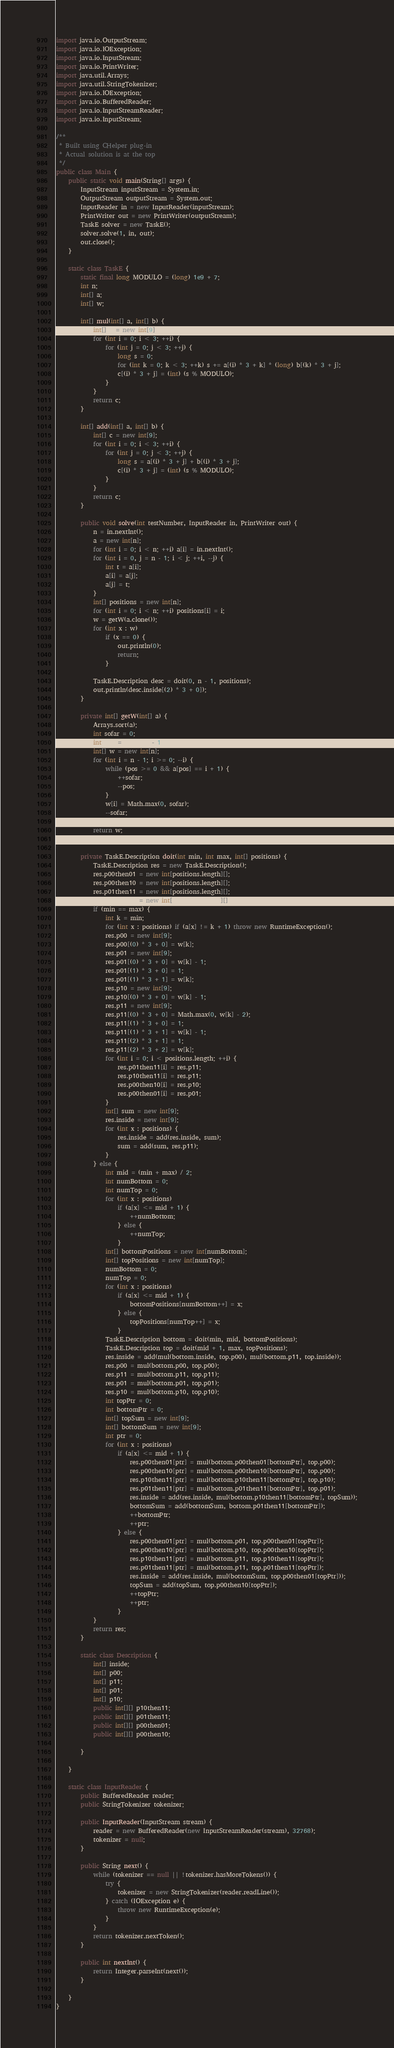<code> <loc_0><loc_0><loc_500><loc_500><_Java_>import java.io.OutputStream;
import java.io.IOException;
import java.io.InputStream;
import java.io.PrintWriter;
import java.util.Arrays;
import java.util.StringTokenizer;
import java.io.IOException;
import java.io.BufferedReader;
import java.io.InputStreamReader;
import java.io.InputStream;

/**
 * Built using CHelper plug-in
 * Actual solution is at the top
 */
public class Main {
    public static void main(String[] args) {
        InputStream inputStream = System.in;
        OutputStream outputStream = System.out;
        InputReader in = new InputReader(inputStream);
        PrintWriter out = new PrintWriter(outputStream);
        TaskE solver = new TaskE();
        solver.solve(1, in, out);
        out.close();
    }

    static class TaskE {
        static final long MODULO = (long) 1e9 + 7;
        int n;
        int[] a;
        int[] w;

        int[] mul(int[] a, int[] b) {
            int[] c = new int[9];
            for (int i = 0; i < 3; ++i) {
                for (int j = 0; j < 3; ++j) {
                    long s = 0;
                    for (int k = 0; k < 3; ++k) s += a[(i) * 3 + k] * (long) b[(k) * 3 + j];
                    c[(i) * 3 + j] = (int) (s % MODULO);
                }
            }
            return c;
        }

        int[] add(int[] a, int[] b) {
            int[] c = new int[9];
            for (int i = 0; i < 3; ++i) {
                for (int j = 0; j < 3; ++j) {
                    long s = a[(i) * 3 + j] + b[(i) * 3 + j];
                    c[(i) * 3 + j] = (int) (s % MODULO);
                }
            }
            return c;
        }

        public void solve(int testNumber, InputReader in, PrintWriter out) {
            n = in.nextInt();
            a = new int[n];
            for (int i = 0; i < n; ++i) a[i] = in.nextInt();
            for (int i = 0, j = n - 1; i < j; ++i, --j) {
                int t = a[i];
                a[i] = a[j];
                a[j] = t;
            }
            int[] positions = new int[n];
            for (int i = 0; i < n; ++i) positions[i] = i;
            w = getW(a.clone());
            for (int x : w)
                if (x == 0) {
                    out.println(0);
                    return;
                }

            TaskE.Description desc = doit(0, n - 1, positions);
            out.println(desc.inside[(2) * 3 + 0]);
        }

        private int[] getW(int[] a) {
            Arrays.sort(a);
            int sofar = 0;
            int pos = a.length - 1;
            int[] w = new int[n];
            for (int i = n - 1; i >= 0; --i) {
                while (pos >= 0 && a[pos] == i + 1) {
                    ++sofar;
                    --pos;
                }
                w[i] = Math.max(0, sofar);
                --sofar;
            }
            return w;
        }

        private TaskE.Description doit(int min, int max, int[] positions) {
            TaskE.Description res = new TaskE.Description();
            res.p00then01 = new int[positions.length][];
            res.p00then10 = new int[positions.length][];
            res.p01then11 = new int[positions.length][];
            res.p10then11 = new int[positions.length][];
            if (min == max) {
                int k = min;
                for (int x : positions) if (a[x] != k + 1) throw new RuntimeException();
                res.p00 = new int[9];
                res.p00[(0) * 3 + 0] = w[k];
                res.p01 = new int[9];
                res.p01[(0) * 3 + 0] = w[k] - 1;
                res.p01[(1) * 3 + 0] = 1;
                res.p01[(1) * 3 + 1] = w[k];
                res.p10 = new int[9];
                res.p10[(0) * 3 + 0] = w[k] - 1;
                res.p11 = new int[9];
                res.p11[(0) * 3 + 0] = Math.max(0, w[k] - 2);
                res.p11[(1) * 3 + 0] = 1;
                res.p11[(1) * 3 + 1] = w[k] - 1;
                res.p11[(2) * 3 + 1] = 1;
                res.p11[(2) * 3 + 2] = w[k];
                for (int i = 0; i < positions.length; ++i) {
                    res.p01then11[i] = res.p11;
                    res.p10then11[i] = res.p11;
                    res.p00then10[i] = res.p10;
                    res.p00then01[i] = res.p01;
                }
                int[] sum = new int[9];
                res.inside = new int[9];
                for (int x : positions) {
                    res.inside = add(res.inside, sum);
                    sum = add(sum, res.p11);
                }
            } else {
                int mid = (min + max) / 2;
                int numBottom = 0;
                int numTop = 0;
                for (int x : positions)
                    if (a[x] <= mid + 1) {
                        ++numBottom;
                    } else {
                        ++numTop;
                    }
                int[] bottomPositions = new int[numBottom];
                int[] topPositions = new int[numTop];
                numBottom = 0;
                numTop = 0;
                for (int x : positions)
                    if (a[x] <= mid + 1) {
                        bottomPositions[numBottom++] = x;
                    } else {
                        topPositions[numTop++] = x;
                    }
                TaskE.Description bottom = doit(min, mid, bottomPositions);
                TaskE.Description top = doit(mid + 1, max, topPositions);
                res.inside = add(mul(bottom.inside, top.p00), mul(bottom.p11, top.inside));
                res.p00 = mul(bottom.p00, top.p00);
                res.p11 = mul(bottom.p11, top.p11);
                res.p01 = mul(bottom.p01, top.p01);
                res.p10 = mul(bottom.p10, top.p10);
                int topPtr = 0;
                int bottomPtr = 0;
                int[] topSum = new int[9];
                int[] bottomSum = new int[9];
                int ptr = 0;
                for (int x : positions)
                    if (a[x] <= mid + 1) {
                        res.p00then01[ptr] = mul(bottom.p00then01[bottomPtr], top.p00);
                        res.p00then10[ptr] = mul(bottom.p00then10[bottomPtr], top.p00);
                        res.p10then11[ptr] = mul(bottom.p10then11[bottomPtr], top.p10);
                        res.p01then11[ptr] = mul(bottom.p01then11[bottomPtr], top.p01);
                        res.inside = add(res.inside, mul(bottom.p10then11[bottomPtr], topSum));
                        bottomSum = add(bottomSum, bottom.p01then11[bottomPtr]);
                        ++bottomPtr;
                        ++ptr;
                    } else {
                        res.p00then01[ptr] = mul(bottom.p01, top.p00then01[topPtr]);
                        res.p00then10[ptr] = mul(bottom.p10, top.p00then10[topPtr]);
                        res.p10then11[ptr] = mul(bottom.p11, top.p10then11[topPtr]);
                        res.p01then11[ptr] = mul(bottom.p11, top.p01then11[topPtr]);
                        res.inside = add(res.inside, mul(bottomSum, top.p00then01[topPtr]));
                        topSum = add(topSum, top.p00then10[topPtr]);
                        ++topPtr;
                        ++ptr;
                    }
            }
            return res;
        }

        static class Description {
            int[] inside;
            int[] p00;
            int[] p11;
            int[] p01;
            int[] p10;
            public int[][] p10then11;
            public int[][] p01then11;
            public int[][] p00then01;
            public int[][] p00then10;

        }

    }

    static class InputReader {
        public BufferedReader reader;
        public StringTokenizer tokenizer;

        public InputReader(InputStream stream) {
            reader = new BufferedReader(new InputStreamReader(stream), 32768);
            tokenizer = null;
        }

        public String next() {
            while (tokenizer == null || !tokenizer.hasMoreTokens()) {
                try {
                    tokenizer = new StringTokenizer(reader.readLine());
                } catch (IOException e) {
                    throw new RuntimeException(e);
                }
            }
            return tokenizer.nextToken();
        }

        public int nextInt() {
            return Integer.parseInt(next());
        }

    }
}

</code> 